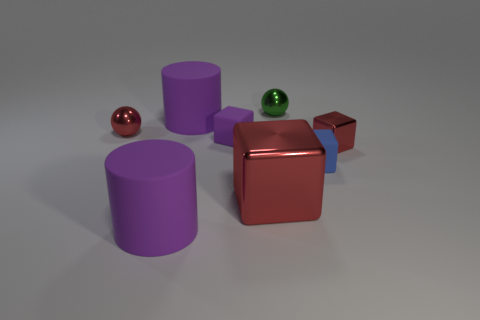What material is the purple cube that is the same size as the blue matte object?
Your answer should be very brief. Rubber. Is there another purple rubber block that has the same size as the purple block?
Your answer should be very brief. No. The green shiny object that is the same size as the red ball is what shape?
Provide a succinct answer. Sphere. What number of other things are there of the same color as the large metallic block?
Your response must be concise. 2. What is the shape of the metallic thing that is both behind the tiny purple object and in front of the tiny green metal ball?
Your answer should be very brief. Sphere. There is a red shiny object that is in front of the small metal object right of the small green metal thing; is there a metallic object that is on the right side of it?
Make the answer very short. Yes. What number of other objects are there of the same material as the tiny purple thing?
Ensure brevity in your answer.  3. How many large blue matte spheres are there?
Offer a very short reply. 0. How many things are large red shiny things or red metal blocks to the left of the green metal thing?
Your answer should be compact. 1. Is there anything else that is the same shape as the large red shiny thing?
Keep it short and to the point. Yes. 